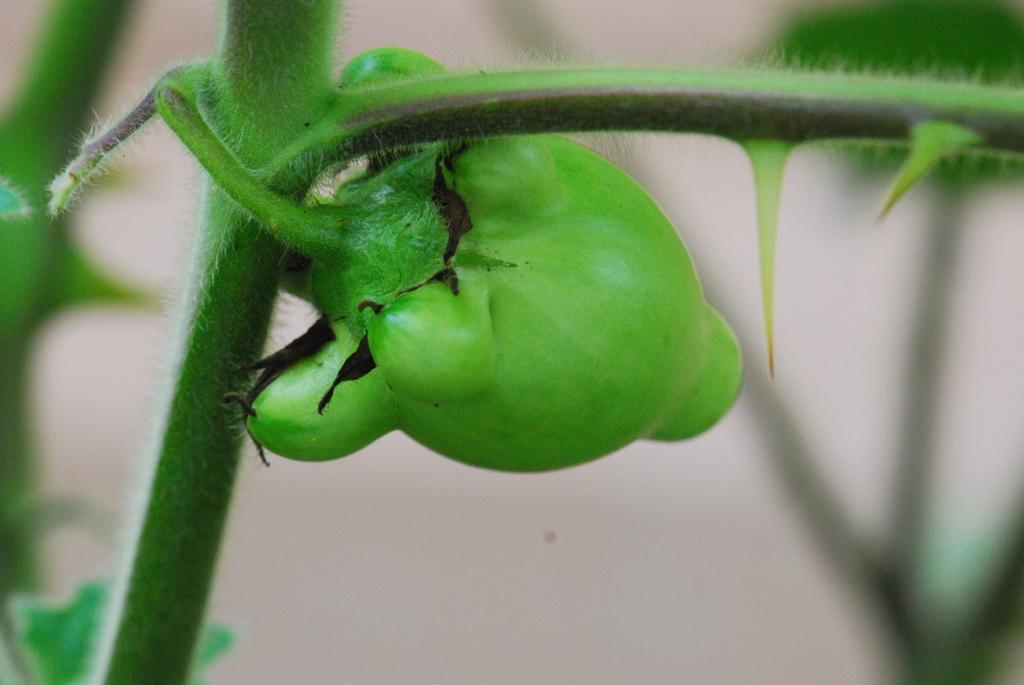What type of living organism can be seen in the image? There is a vegetable on a plant in the image. Can you describe the vegetable's growth stage? The provided facts do not specify the vegetable's growth stage. What is the primary setting of the image? The image is set in a plant or garden where the vegetable is growing. What invention is being demonstrated by the zebra in the image? There is no zebra present in the image, and therefore no invention can be demonstrated by a zebra. 